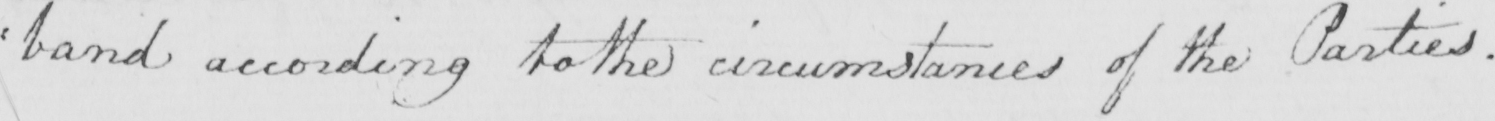Please transcribe the handwritten text in this image. : band according to the circumstances of the Parties . 